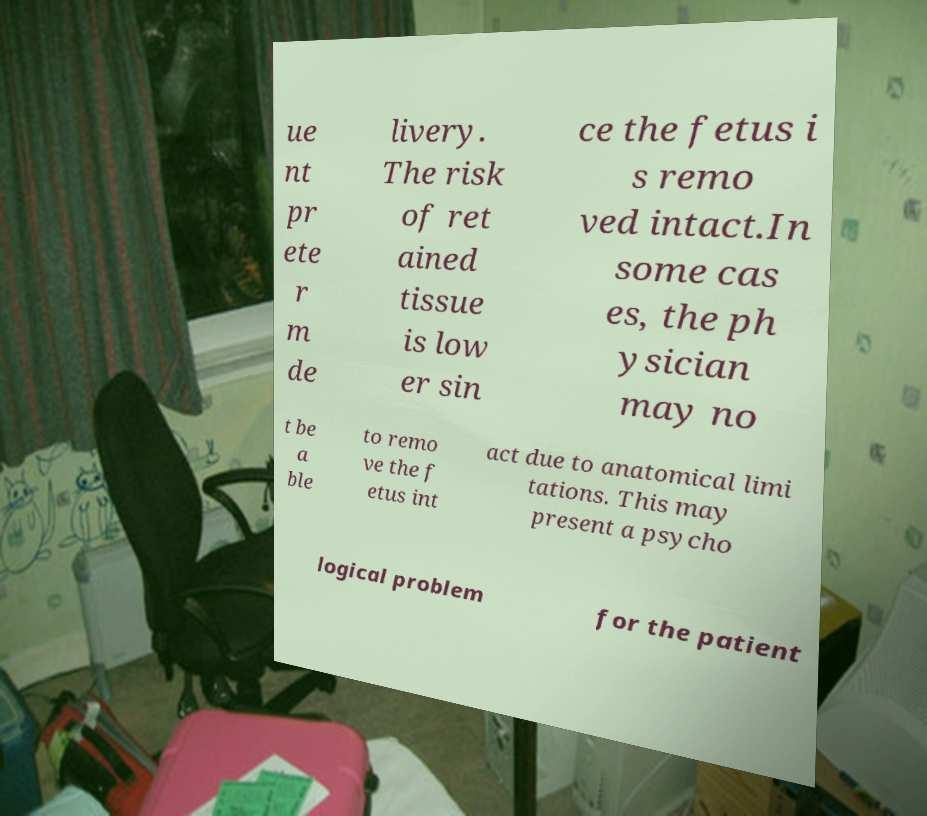Please read and relay the text visible in this image. What does it say? ue nt pr ete r m de livery. The risk of ret ained tissue is low er sin ce the fetus i s remo ved intact.In some cas es, the ph ysician may no t be a ble to remo ve the f etus int act due to anatomical limi tations. This may present a psycho logical problem for the patient 